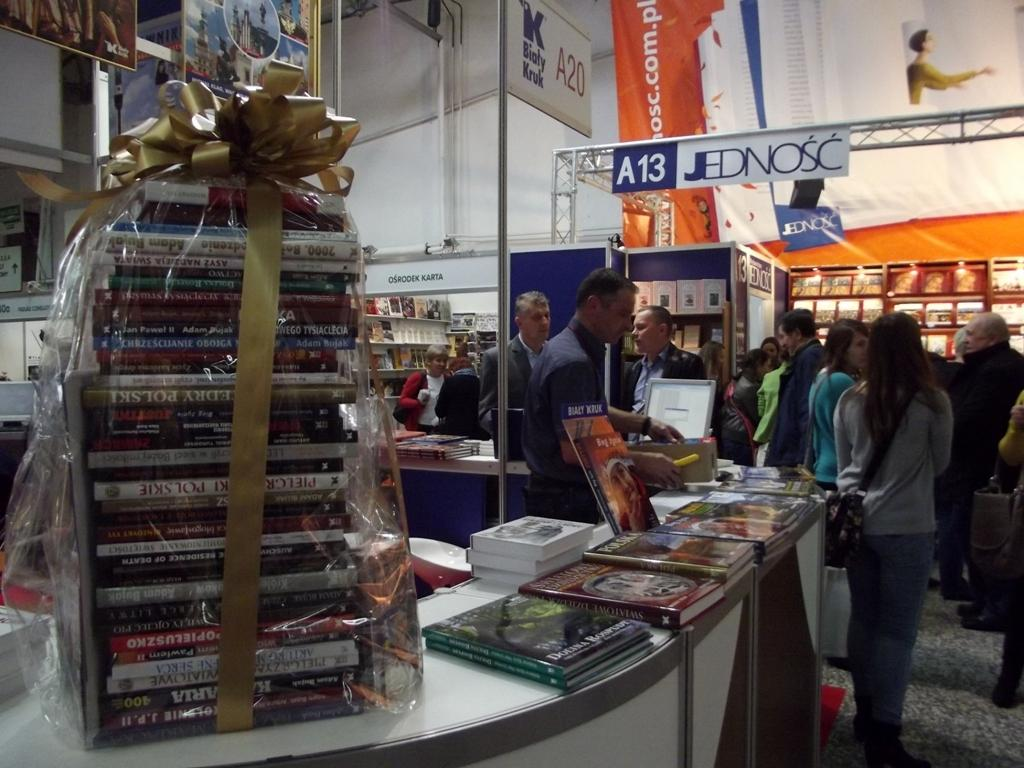<image>
Summarize the visual content of the image. Display at a sales event to sell dvd next to a sign reading A13 Jednosc 